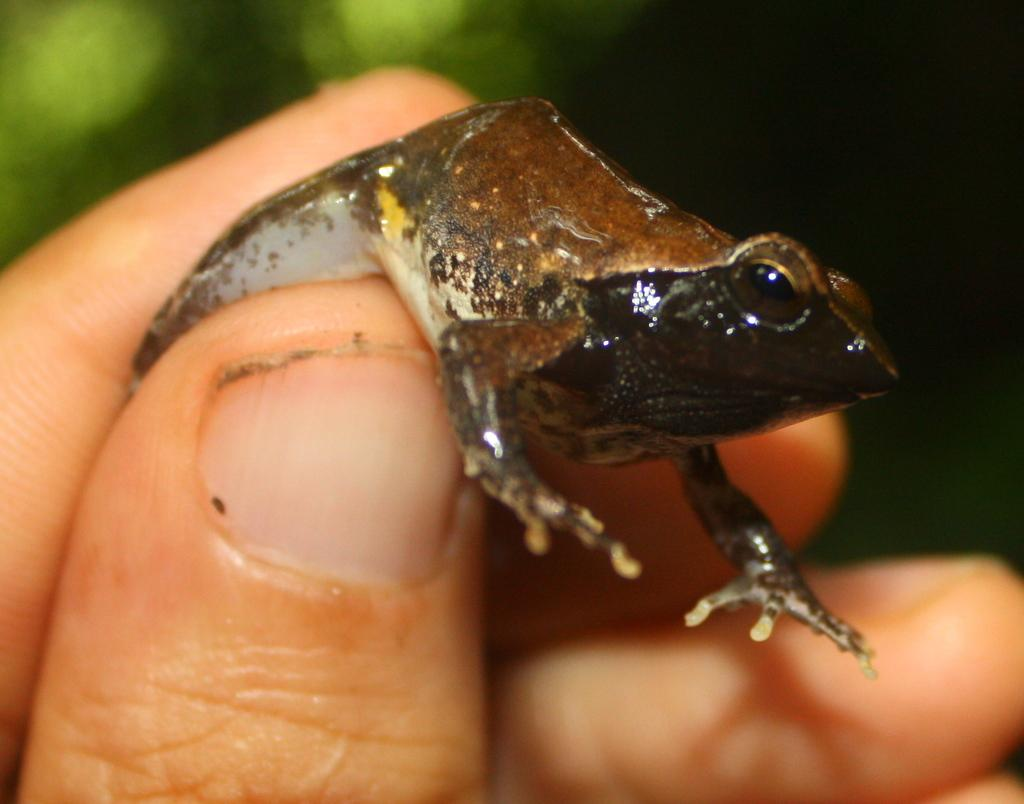What is the person's hand holding in the image? There is a person's hand holding a frog in the image. Can you describe the background of the image? The background of the image is blurred. What type of music is the monkey playing in the image? There is no monkey or music present in the image; it only features a person's hand holding a frog with a blurred background. 